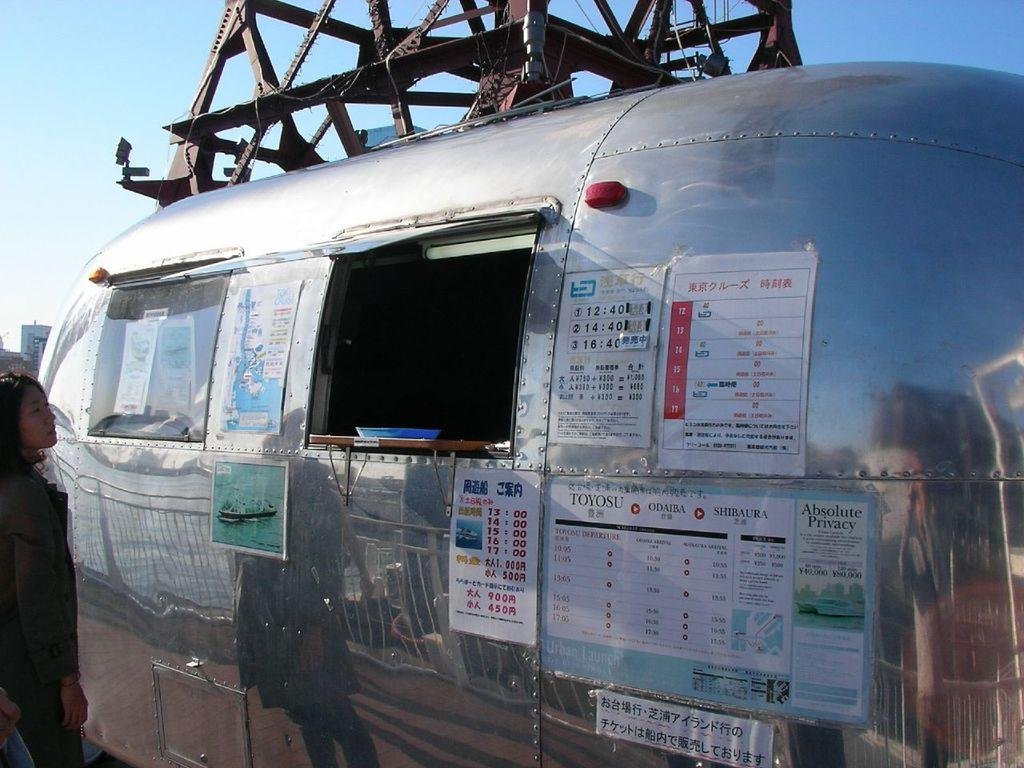What is the main subject in the image? There is a vehicle in the image. Can you describe the lady standing on the left side of the image? The lady is standing on the left side of the image. What can be seen in the background of the image? There are buildings and the sky visible in the background of the image. What type of cherry tree is providing shade for the vehicle in the image? There is no cherry tree or shade present in the image. Can you make a comparison between the vehicle and the lady in the image? The provided facts do not allow for a comparison between the vehicle and the lady in the image. 